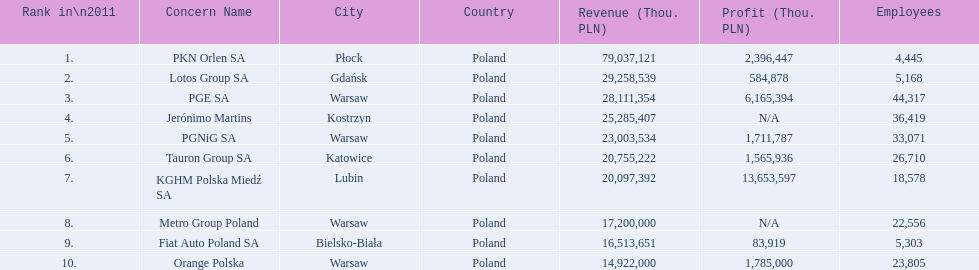Which company had the least revenue? Orange Polska. I'm looking to parse the entire table for insights. Could you assist me with that? {'header': ['Rank in\\n2011', 'Concern Name', 'City', 'Country', 'Revenue (Thou. PLN)', 'Profit (Thou. PLN)', 'Employees'], 'rows': [['1.', 'PKN Orlen SA', 'Płock', 'Poland', '79,037,121', '2,396,447', '4,445'], ['2.', 'Lotos Group SA', 'Gdańsk', 'Poland', '29,258,539', '584,878', '5,168'], ['3.', 'PGE SA', 'Warsaw', 'Poland', '28,111,354', '6,165,394', '44,317'], ['4.', 'Jerónimo Martins', 'Kostrzyn', 'Poland', '25,285,407', 'N/A', '36,419'], ['5.', 'PGNiG SA', 'Warsaw', 'Poland', '23,003,534', '1,711,787', '33,071'], ['6.', 'Tauron Group SA', 'Katowice', 'Poland', '20,755,222', '1,565,936', '26,710'], ['7.', 'KGHM Polska Miedź SA', 'Lubin', 'Poland', '20,097,392', '13,653,597', '18,578'], ['8.', 'Metro Group Poland', 'Warsaw', 'Poland', '17,200,000', 'N/A', '22,556'], ['9.', 'Fiat Auto Poland SA', 'Bielsko-Biała', 'Poland', '16,513,651', '83,919', '5,303'], ['10.', 'Orange Polska', 'Warsaw', 'Poland', '14,922,000', '1,785,000', '23,805']]} 